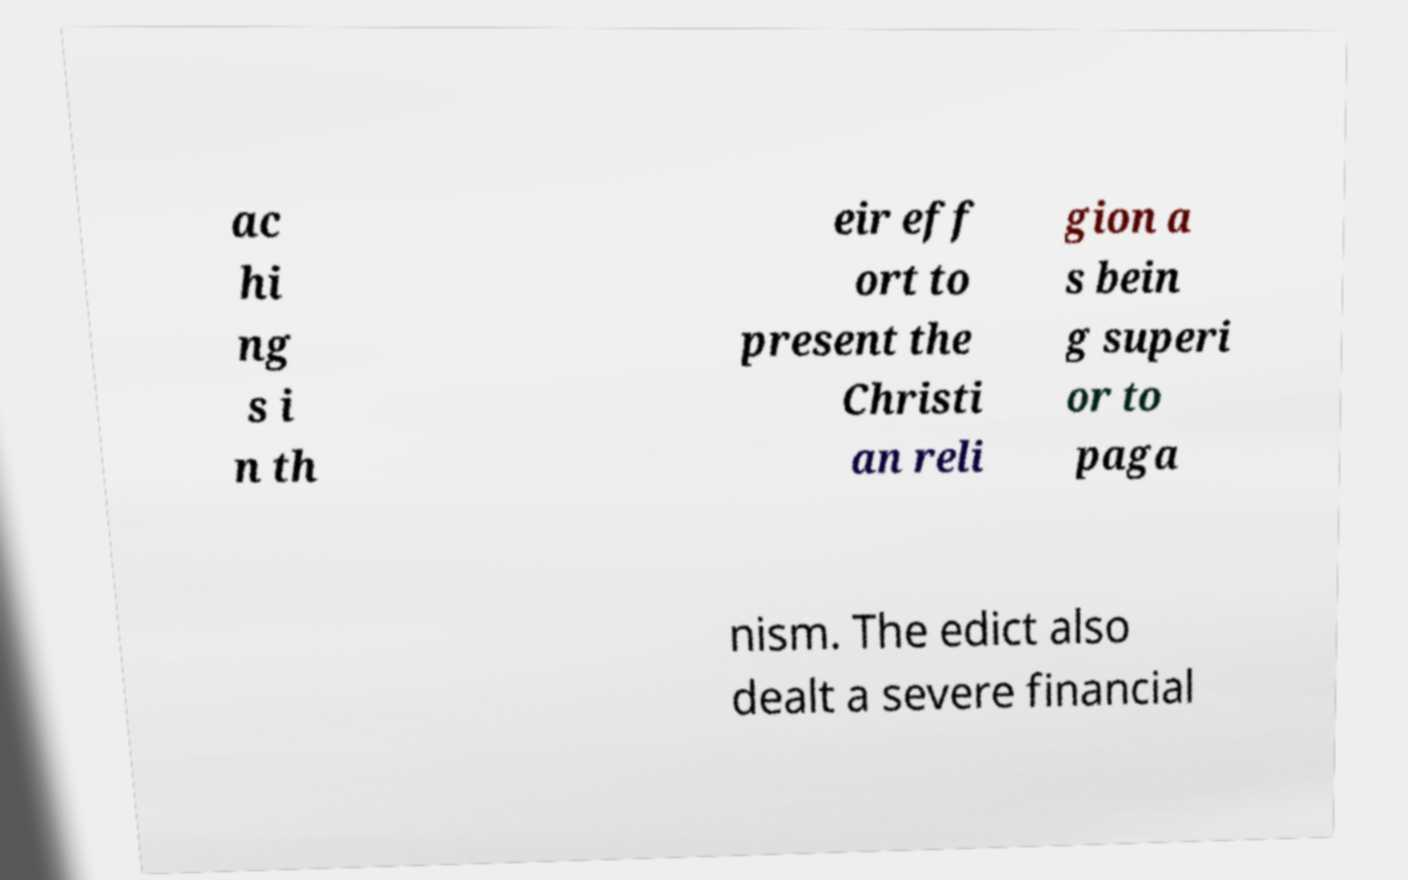Could you extract and type out the text from this image? ac hi ng s i n th eir eff ort to present the Christi an reli gion a s bein g superi or to paga nism. The edict also dealt a severe financial 